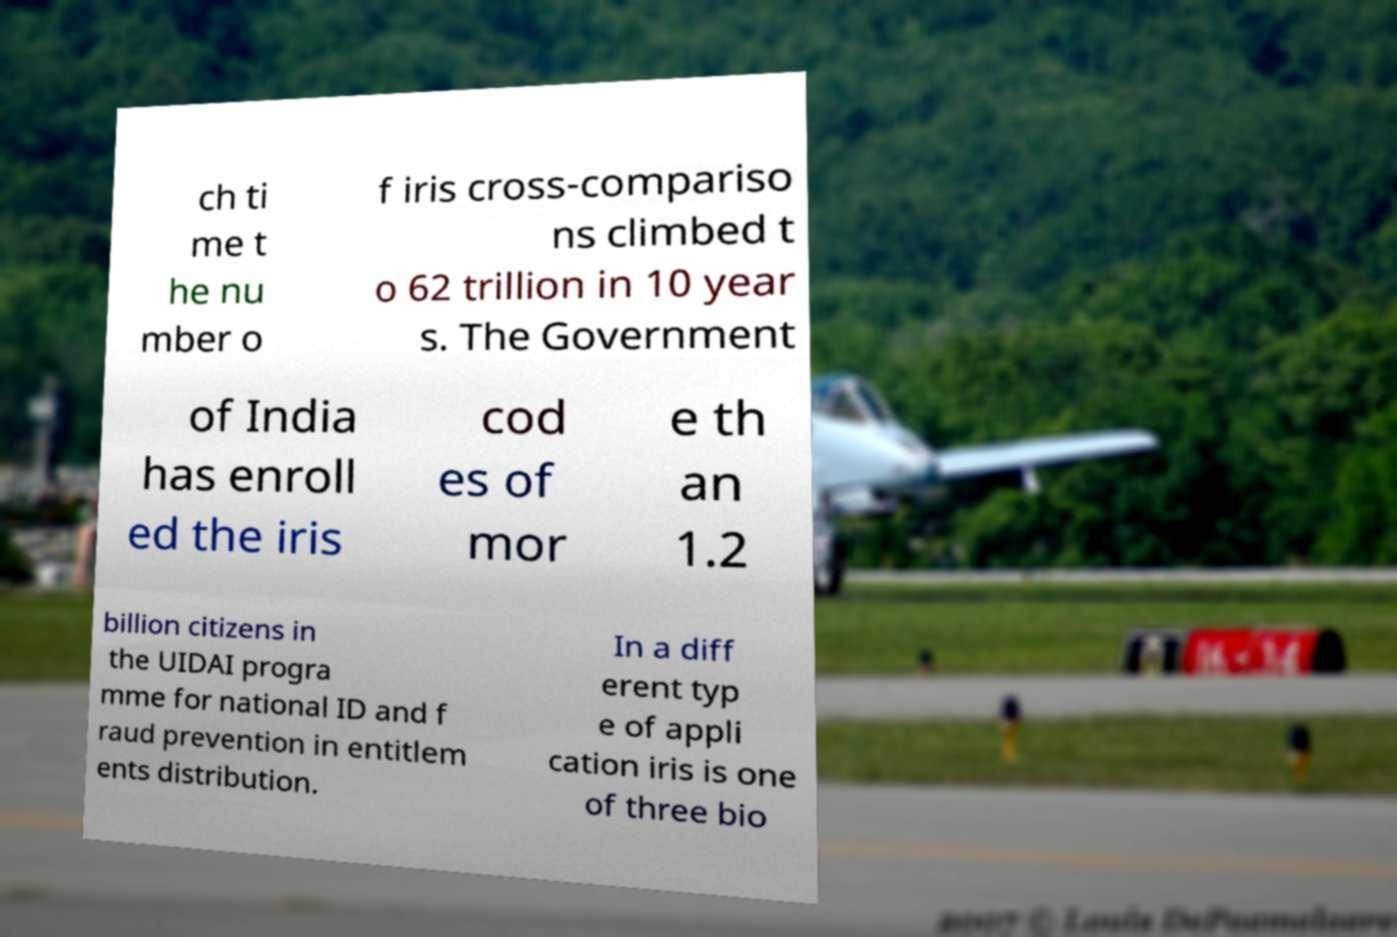I need the written content from this picture converted into text. Can you do that? ch ti me t he nu mber o f iris cross-compariso ns climbed t o 62 trillion in 10 year s. The Government of India has enroll ed the iris cod es of mor e th an 1.2 billion citizens in the UIDAI progra mme for national ID and f raud prevention in entitlem ents distribution. In a diff erent typ e of appli cation iris is one of three bio 